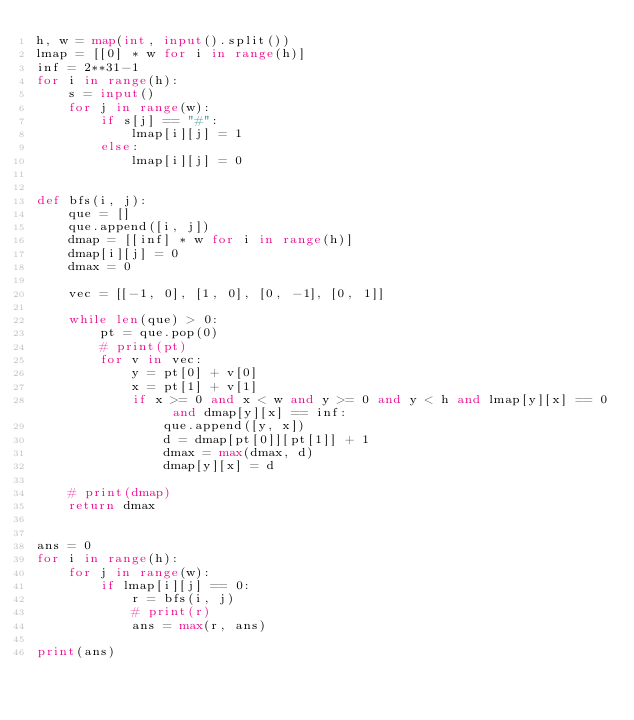<code> <loc_0><loc_0><loc_500><loc_500><_Python_>h, w = map(int, input().split())
lmap = [[0] * w for i in range(h)]
inf = 2**31-1
for i in range(h):
    s = input()
    for j in range(w):
        if s[j] == "#":
            lmap[i][j] = 1
        else:
            lmap[i][j] = 0


def bfs(i, j):
    que = []
    que.append([i, j])
    dmap = [[inf] * w for i in range(h)]
    dmap[i][j] = 0
    dmax = 0

    vec = [[-1, 0], [1, 0], [0, -1], [0, 1]]

    while len(que) > 0:
        pt = que.pop(0)
        # print(pt)
        for v in vec:
            y = pt[0] + v[0]
            x = pt[1] + v[1]
            if x >= 0 and x < w and y >= 0 and y < h and lmap[y][x] == 0 and dmap[y][x] == inf:
                que.append([y, x])
                d = dmap[pt[0]][pt[1]] + 1
                dmax = max(dmax, d)
                dmap[y][x] = d

    # print(dmap)
    return dmax


ans = 0
for i in range(h):
    for j in range(w):
        if lmap[i][j] == 0:
            r = bfs(i, j)
            # print(r)
            ans = max(r, ans)

print(ans)
</code> 